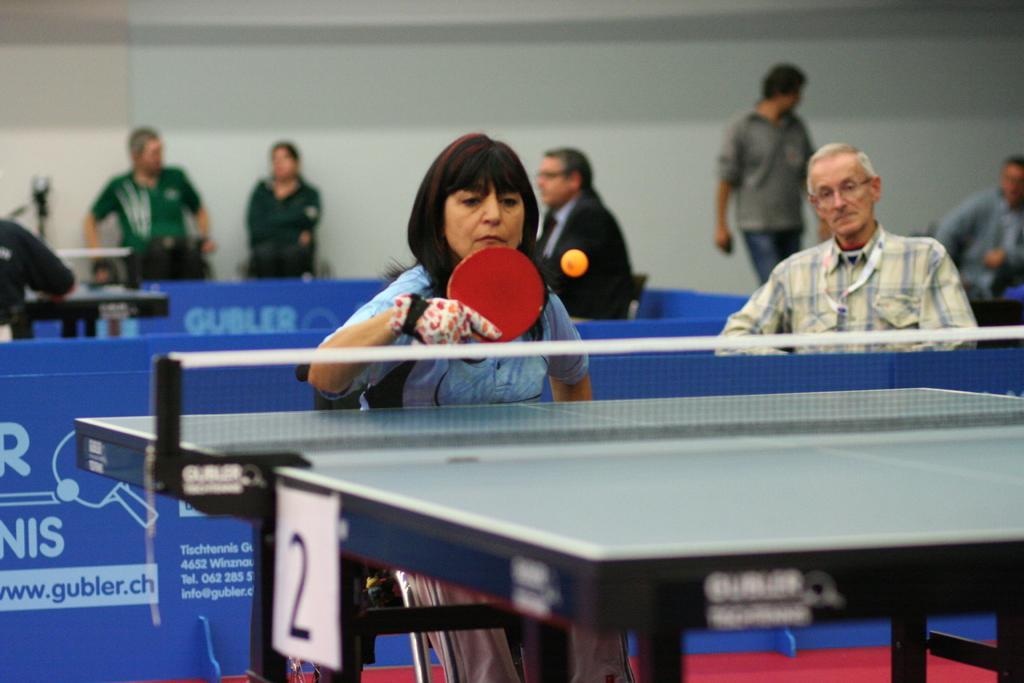How would you summarize this image in a sentence or two? In this image we can see this woman is playing table tennis. There are few more persons in the background. 